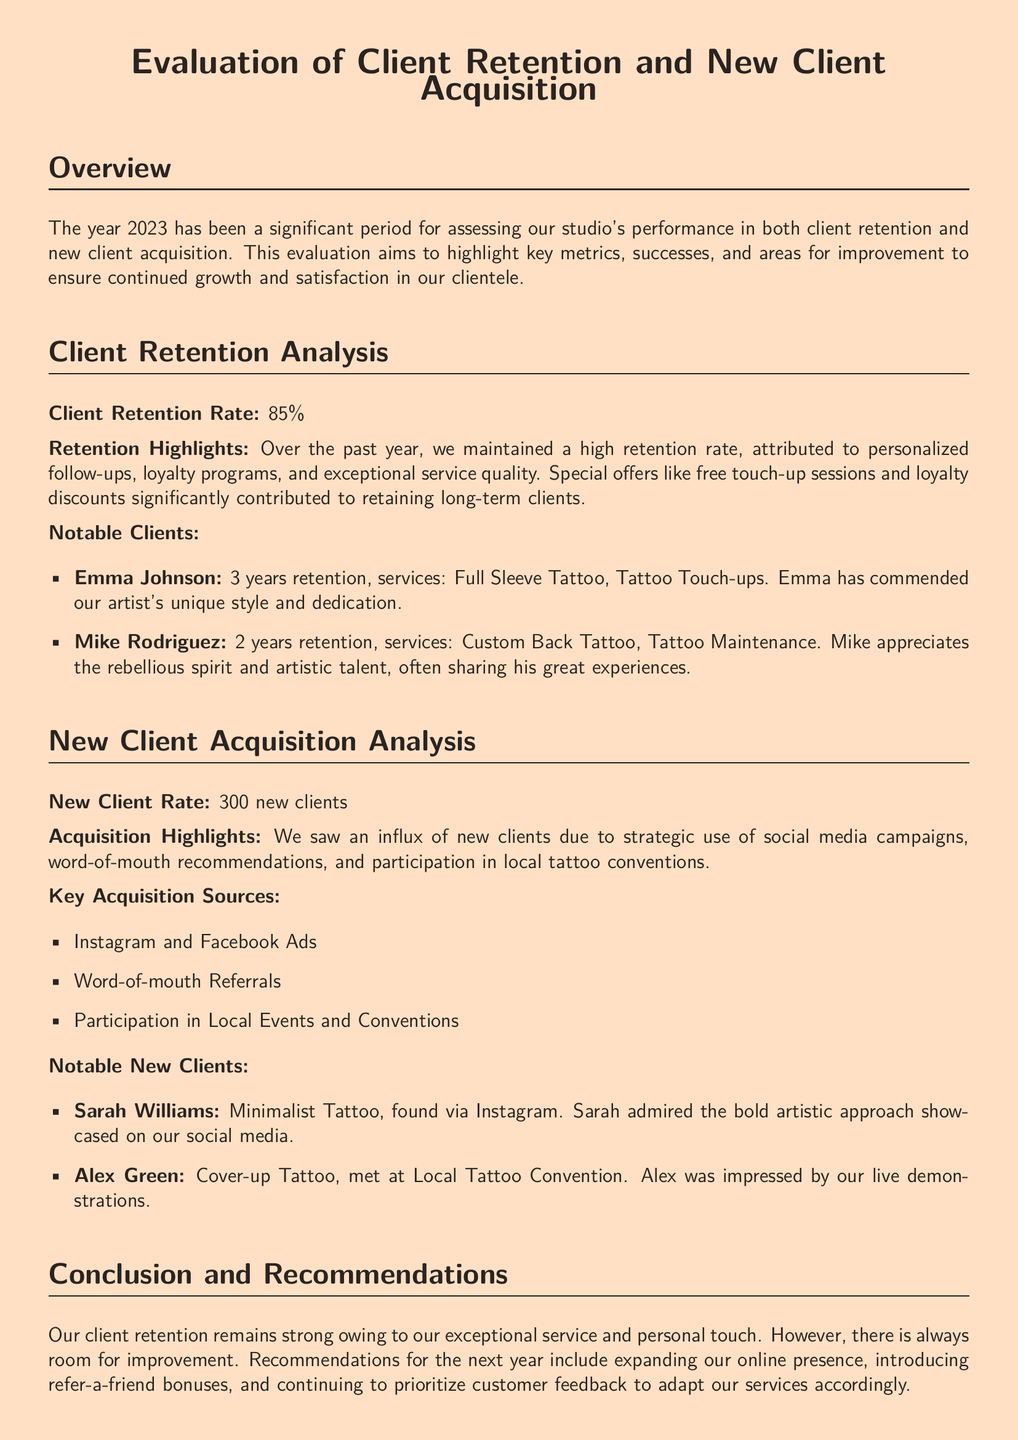What was the client retention rate? The client retention rate is explicitly stated in the document as a percentage.
Answer: 85% How many new clients were acquired? The number of new clients is mentioned in the new client acquisition analysis section.
Answer: 300 What loyalty program offers were mentioned? The document lists specific loyalty program offers that contributed to client retention.
Answer: Free touch-up sessions and loyalty discounts Who is Emma Johnson? The document provides information about notable clients, including their names and services received.
Answer: Full Sleeve Tattoo, Tattoo Touch-ups What marketing strategies contributed to new client acquisition? The document outlines key sources for acquiring new clients, requiring synthesis of information.
Answer: Social media campaigns, word-of-mouth, local tattoo conventions Which notable new client was found via Instagram? The document specifically mentions notable new clients and how they discovered the studio.
Answer: Sarah Williams What should be prioritized according to recommendations for the next year? The conclusions and recommendations section specifies areas of focus for improvement in the coming year.
Answer: Customer feedback How long did Mike Rodriguez retain as a client? The duration of retention for notable clients is explicitly stated in the document.
Answer: 2 years What is the overall conclusion about client retention? The conclusion summarizes the status of client retention and includes an evaluative statement.
Answer: Strong 